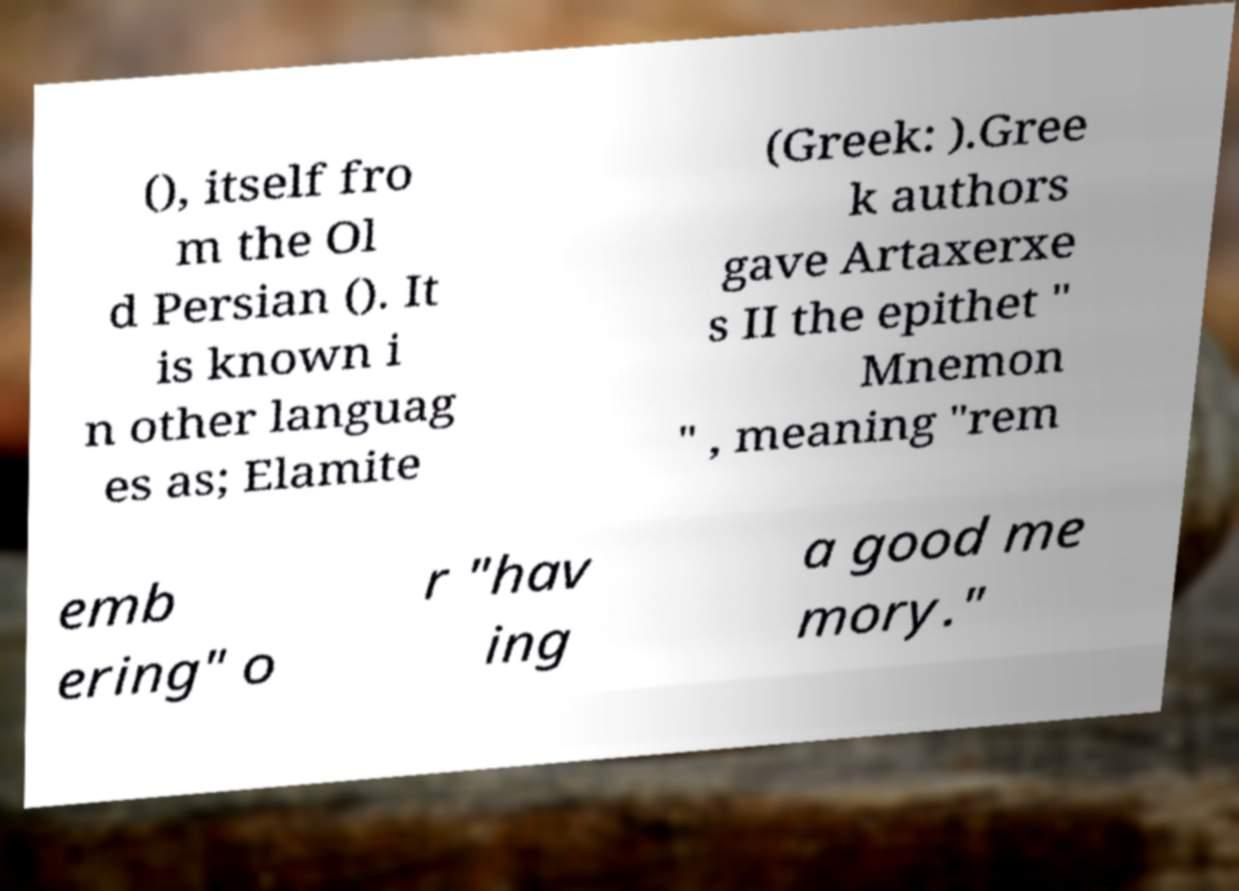Please identify and transcribe the text found in this image. (), itself fro m the Ol d Persian (). It is known i n other languag es as; Elamite (Greek: ).Gree k authors gave Artaxerxe s II the epithet " Mnemon " , meaning "rem emb ering" o r "hav ing a good me mory." 